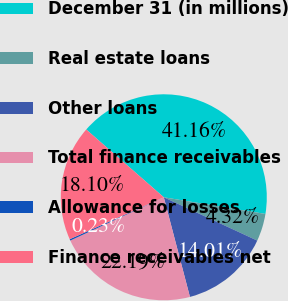Convert chart. <chart><loc_0><loc_0><loc_500><loc_500><pie_chart><fcel>December 31 (in millions)<fcel>Real estate loans<fcel>Other loans<fcel>Total finance receivables<fcel>Allowance for losses<fcel>Finance receivables net<nl><fcel>41.16%<fcel>4.32%<fcel>14.01%<fcel>22.19%<fcel>0.23%<fcel>18.1%<nl></chart> 